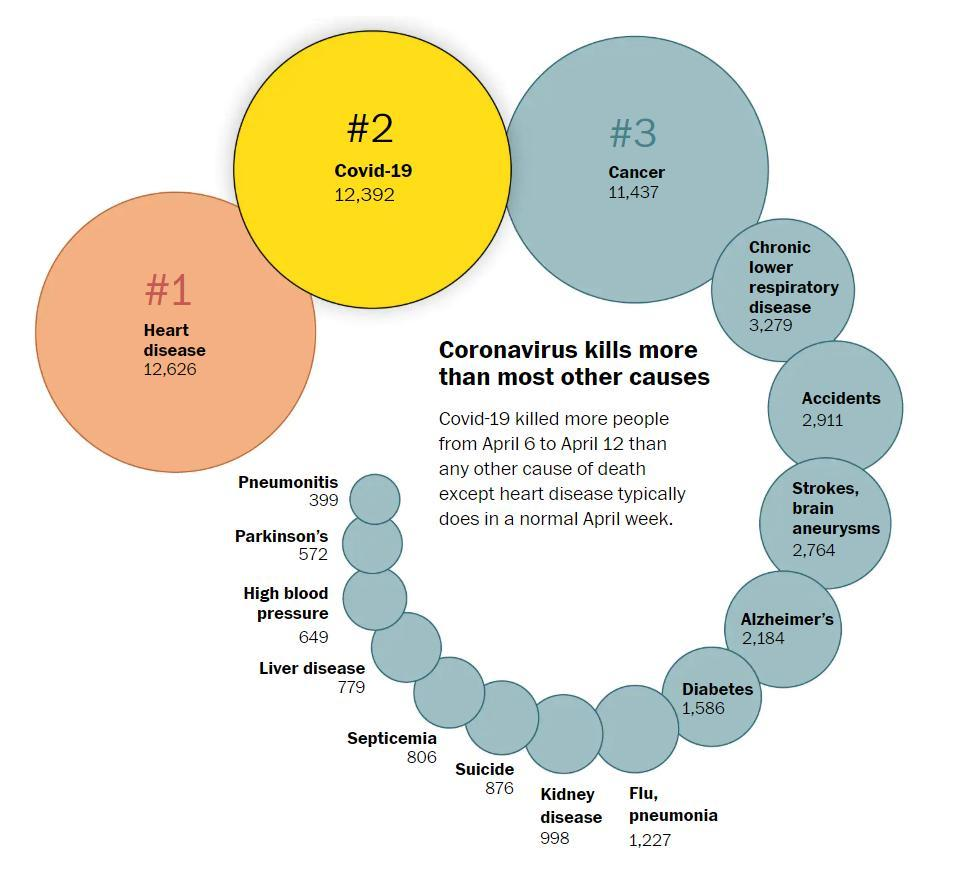How many people were killed by the accidents during April 6-12?
Answer the question with a short phrase. 2,911 Which disease killed most of the people during April 6-12 other than the heart disease & Covid-19? Cancer How many people were killed by suicide during April 6-12? 876 Which disease killed most of the people during April 6-12? Heart disease Which disease killed the least number of people in a normal April week? Pneumonitis How many people were killed by the liver disease during April 6-12? 779 